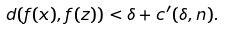Convert formula to latex. <formula><loc_0><loc_0><loc_500><loc_500>d ( f ( x ) , f ( z ) ) < \delta + c ^ { \prime } ( \delta , n ) .</formula> 